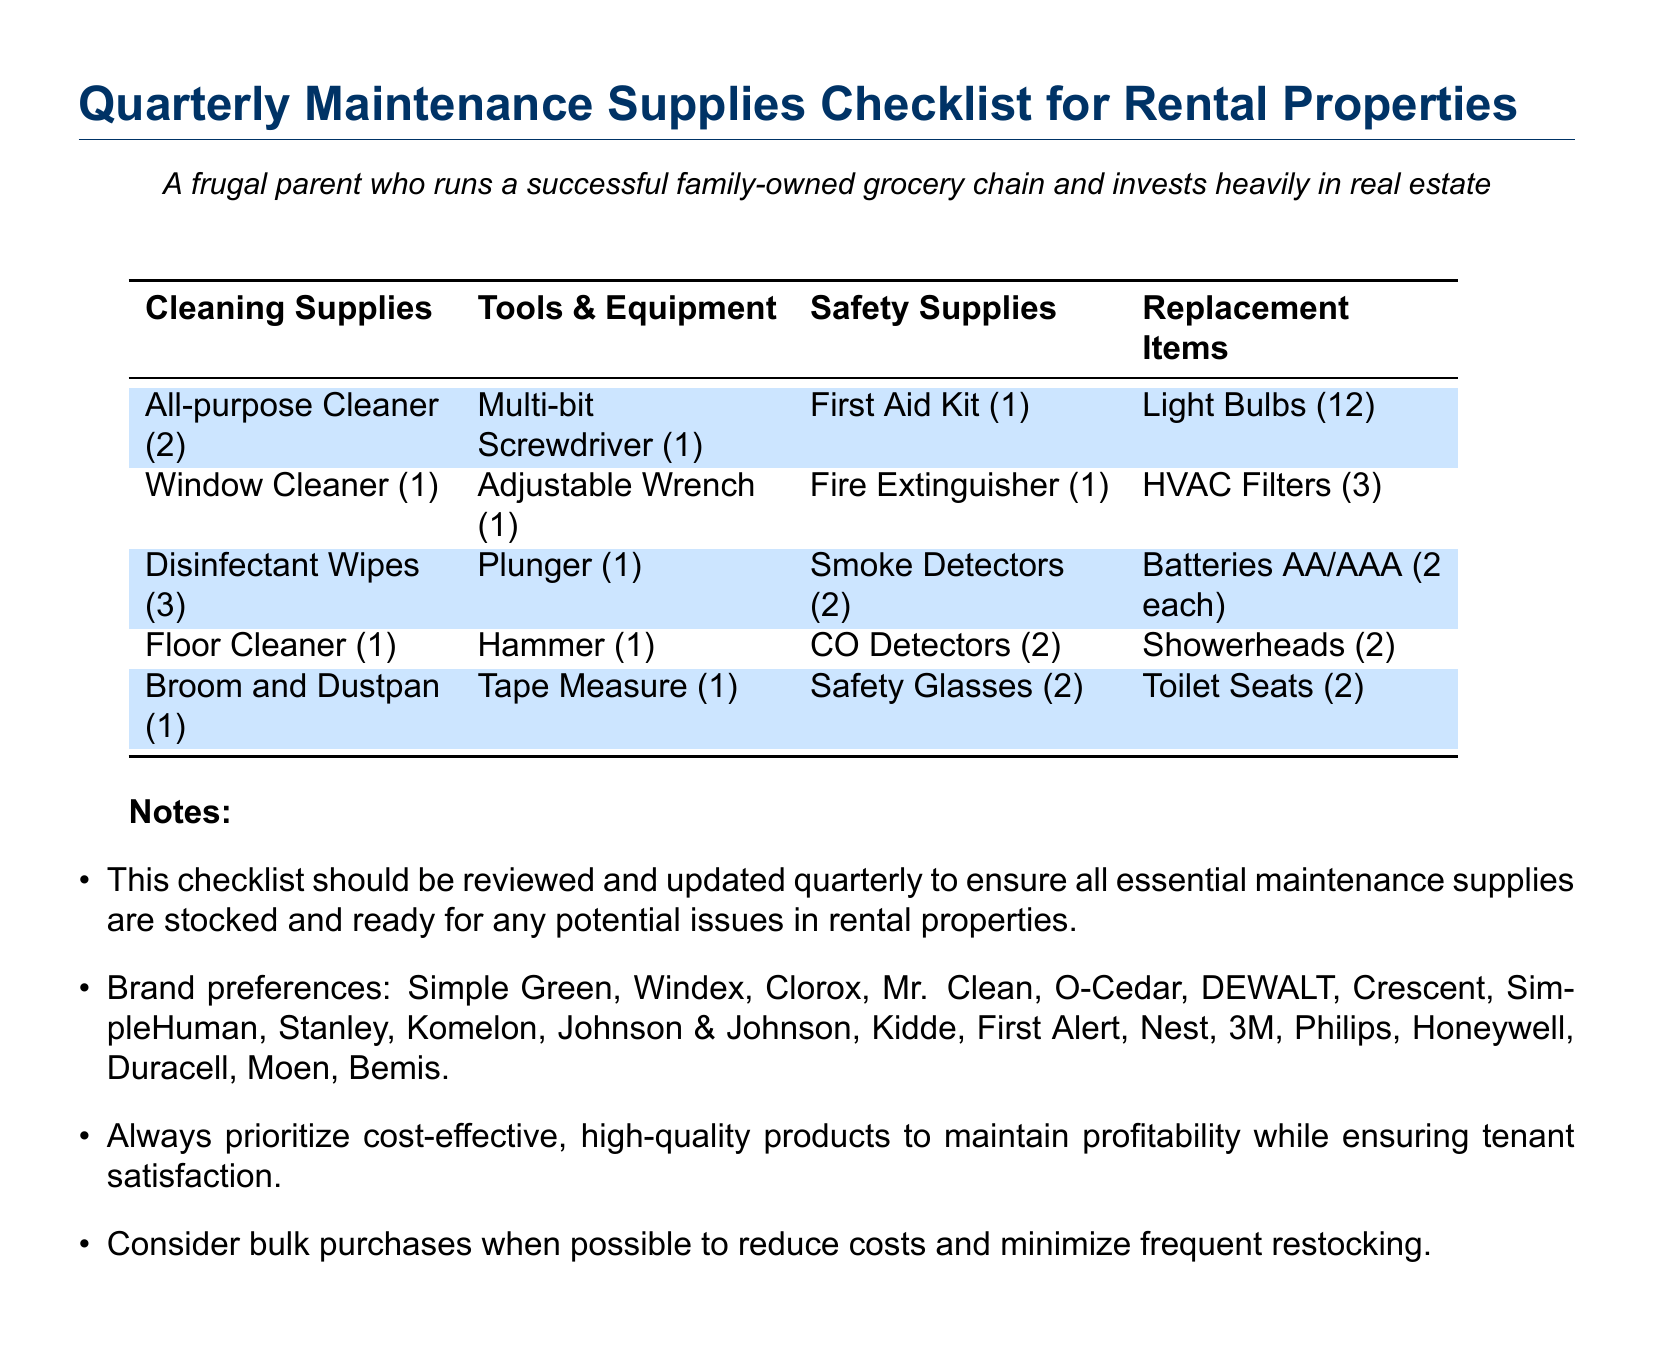What are the cleaning supplies listed? The cleaning supplies are contained in the first column of the table, which includes items like All-purpose Cleaner and Window Cleaner.
Answer: All-purpose Cleaner, Window Cleaner, Disinfectant Wipes, Floor Cleaner, Broom and Dustpan How many light bulbs are included in the replacement items? The replacement items section lists Light Bulbs, and the quantity specified is 12.
Answer: 12 What is one tool listed in the tools & equipment category? The tools & equipment section includes various tools, for example, the Multi-bit Screwdriver.
Answer: Multi-bit Screwdriver How many smoke detectors are recommended? The safety supplies section indicates that 2 Smoke Detectors are necessary for rental properties.
Answer: 2 What is the total number of batteries required for both AA and AAA? The batteries section specifies quantities for both AA and AAA, stating 2 for each, making a total of 4.
Answer: 4 Who are some of the brand preferences mentioned in the notes? The notes provide various brand names like Simple Green and Windex under brand preferences.
Answer: Simple Green, Windex How often should the checklist be reviewed? The notes suggest that the checklist should be reviewed and updated quarterly.
Answer: Quarterly What additional supply is included under safety supplies besides the first aid kit? The safety supplies category contains multiple items, including Fire Extinguisher in addition to the First Aid Kit.
Answer: Fire Extinguisher What is a priority when selecting products listed in the notes? The notes highlight prioritizing cost-effective, high-quality products to maintain profitability.
Answer: Cost-effective, high-quality products 